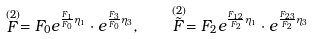<formula> <loc_0><loc_0><loc_500><loc_500>\stackrel { ( 2 ) } { F } = F _ { 0 } e ^ { \frac { F _ { 1 } } { F _ { 0 } } \eta _ { 1 } } \cdot e ^ { \frac { F _ { 3 } } { F _ { 0 } } \eta _ { 3 } } , \quad \stackrel { ( 2 ) } { \tilde { F } } = F _ { 2 } e ^ { \frac { F _ { 1 2 } } { F _ { 2 } } \eta _ { 1 } } \cdot e ^ { \frac { F _ { 2 3 } } { F _ { 2 } } \eta _ { 3 } }</formula> 